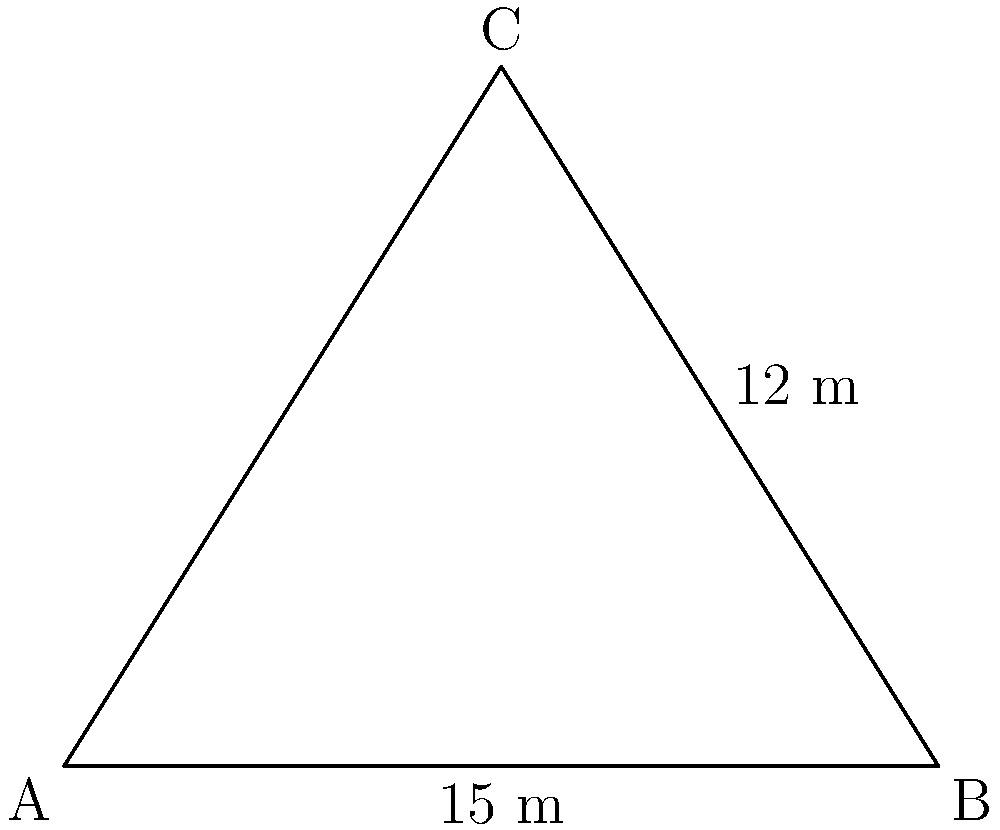In a forensic investigation of a shooting incident, a bullet hole was found 12 meters above ground level on a vertical wall. The distance from the base of the wall to where the shooter was believed to have stood is 15 meters. Using trigonometric ratios, calculate the angle of impact ($\theta$) of the bullet with respect to the ground. To solve this problem, we can use the trigonometric ratio tangent (tan). Let's approach this step-by-step:

1) In the right-angled triangle formed by the trajectory of the bullet:
   - The opposite side is the height of the bullet hole: 12 meters
   - The adjacent side is the distance from the wall to the shooter: 15 meters
   - The angle we're looking for ($\theta$) is the angle between the ground and the bullet's trajectory

2) The tangent of an angle in a right-angled triangle is defined as:

   $\tan(\theta) = \frac{\text{opposite}}{\text{adjacent}}$

3) Substituting our values:

   $\tan(\theta) = \frac{12}{15}$

4) To find $\theta$, we need to take the inverse tangent (arctan or $\tan^{-1}$) of both sides:

   $\theta = \tan^{-1}(\frac{12}{15})$

5) Using a calculator or trigonometric tables:

   $\theta \approx 38.66°$

6) Rounding to two decimal places:

   $\theta \approx 38.66°$

Therefore, the angle of impact of the bullet with respect to the ground is approximately 38.66°.
Answer: $38.66°$ 